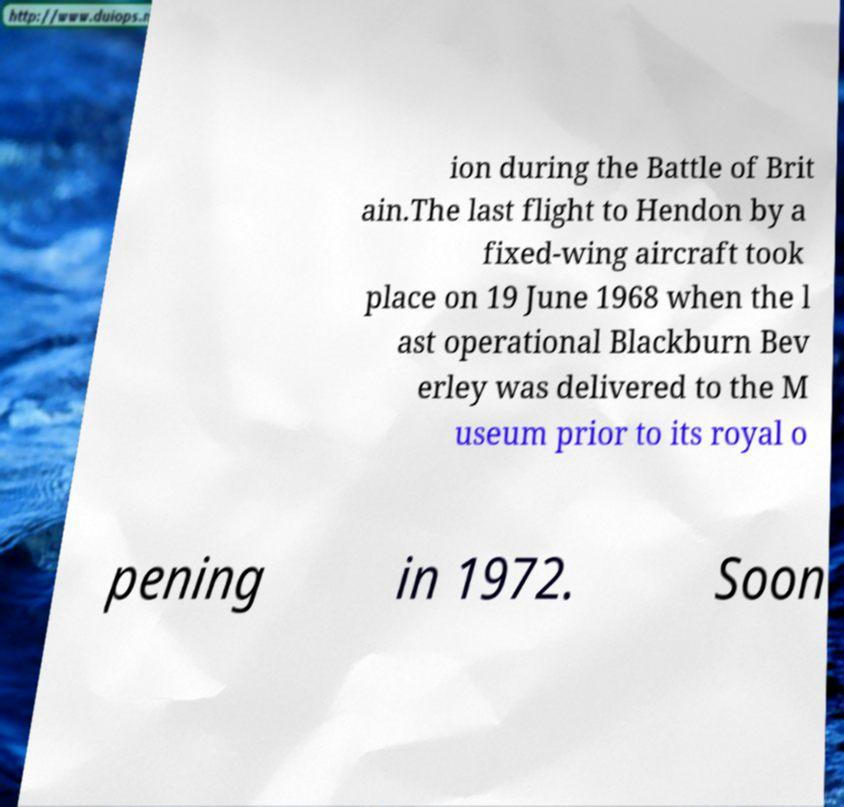What messages or text are displayed in this image? I need them in a readable, typed format. ion during the Battle of Brit ain.The last flight to Hendon by a fixed-wing aircraft took place on 19 June 1968 when the l ast operational Blackburn Bev erley was delivered to the M useum prior to its royal o pening in 1972. Soon 